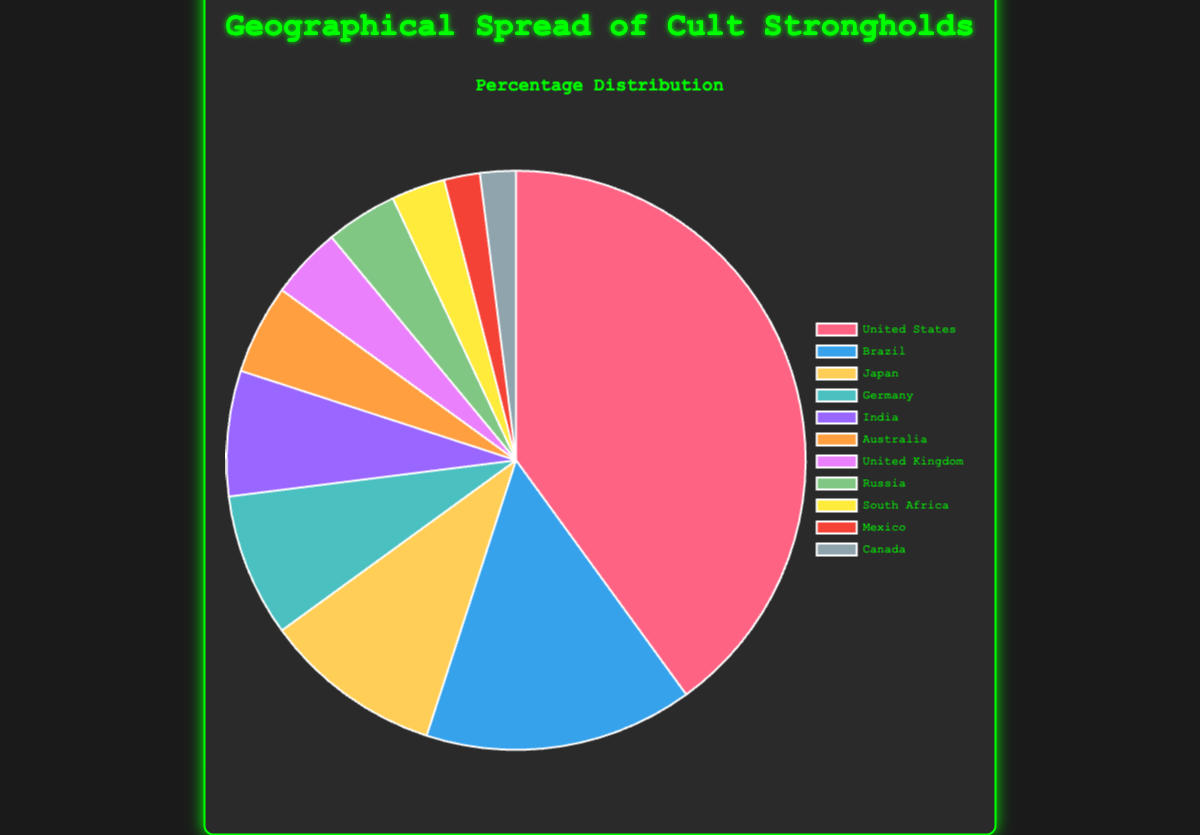Which country has the highest percentage of cult strongholds? The pie chart shows various countries and their corresponding percentages of cult strongholds. The United States has the largest segment.
Answer: The United States What is the combined percentage of cult strongholds in Japan and Germany? The pie chart provides percentages for both Japan (10%) and Germany (8%). Adding these together yields 10% + 8% = 18%.
Answer: 18% How much larger is the percentage of cult strongholds in the United States compared to Brazil? The United States has 40% and Brazil has 15%. The difference is 40% - 15% = 25%.
Answer: 25% Which two regions have equal percentages, and what is that percentage? The pie chart shows Russia and the United Kingdom each holding 4% of the cult strongholds.
Answer: Russia and United Kingdom, 4% Among India, Australia, and South Africa, which region has the smallest percentage of cult strongholds? India has 7%, Australia 5%, and South Africa 3%. Comparing these, South Africa has the smallest percentage.
Answer: South Africa What is the total percentage of cult strongholds in the Americas (United States, Brazil, Mexico, Canada)? United States (40%), Brazil (15%), Mexico (2%), and Canada (2%). Adding these gives 40% + 15% + 2% + 2% = 59%.
Answer: 59% What percentage of cult strongholds are in countries with less than 5% each? Australia (5%), United Kingdom (4%), Russia (4%), South Africa (3%), Mexico (2%), and Canada (2%). Total is 5% + 4% + 4% + 3% + 2% + 2% = 20%.
Answer: 20% What is the average percentage of cult strongholds in Germany, India, and Australia? Germany (8%), India (7%), and Australia (5%). The sum is 8% + 7% + 5% = 20%. Dividing by 3 gives 20% / 3 ≈ 6.67%.
Answer: 6.67% Which region has the sixth highest percentage of cult strongholds? The pie chart ranks percentages from highest to lowest. The sixth highest is Australia with 5%.
Answer: Australia What is the percentage difference between Japan and Russia? Japan (10%) and Russia (4%). The difference is 10% - 4% = 6%.
Answer: 6% 